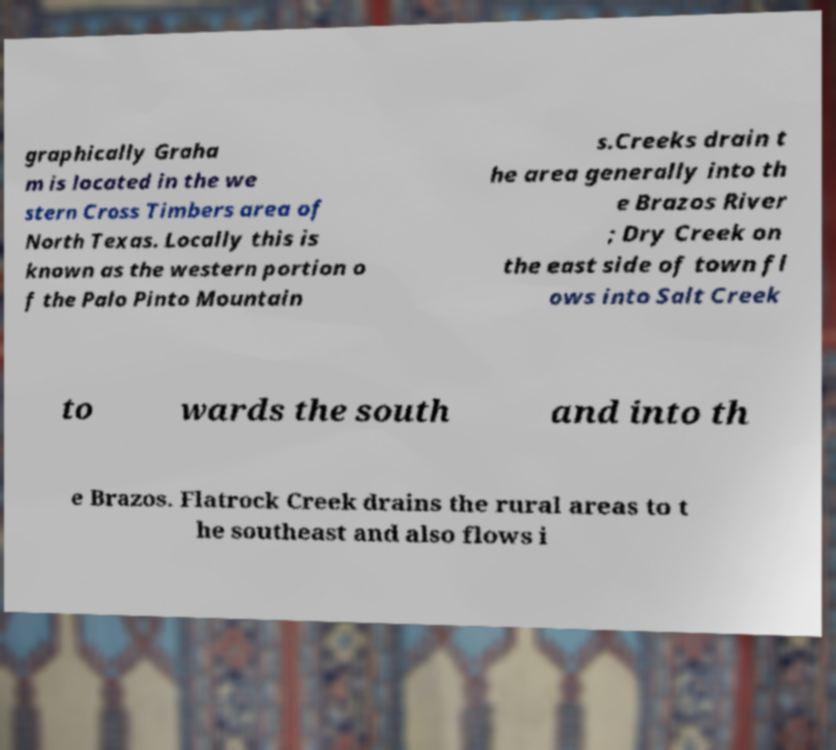Could you extract and type out the text from this image? graphically Graha m is located in the we stern Cross Timbers area of North Texas. Locally this is known as the western portion o f the Palo Pinto Mountain s.Creeks drain t he area generally into th e Brazos River ; Dry Creek on the east side of town fl ows into Salt Creek to wards the south and into th e Brazos. Flatrock Creek drains the rural areas to t he southeast and also flows i 